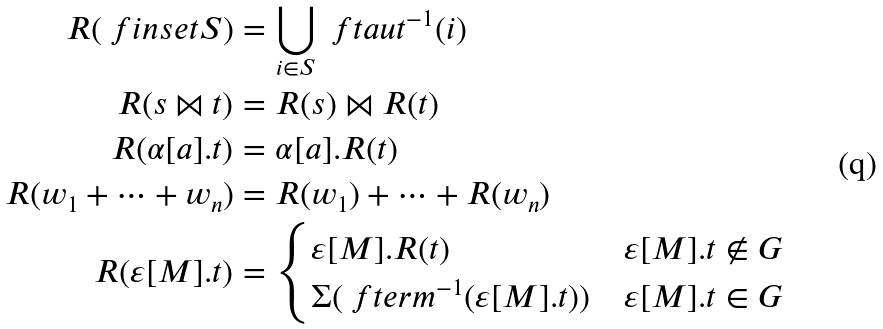Convert formula to latex. <formula><loc_0><loc_0><loc_500><loc_500>R ( \ f i n s e t { S } ) & = \bigcup _ { i \in S } \ f t a u t ^ { - 1 } ( i ) \\ R ( s \bowtie t ) & = R ( s ) \bowtie R ( t ) \\ R ( \alpha [ a ] . t ) & = \alpha [ a ] . R ( t ) \\ R ( w _ { 1 } + \cdots + w _ { n } ) & = R ( w _ { 1 } ) + \cdots + R ( w _ { n } ) \\ R ( \varepsilon [ M ] . t ) & = \begin{cases} \varepsilon [ M ] . R ( t ) & \varepsilon [ M ] . t \notin G \\ \Sigma ( \ f t e r m ^ { - 1 } ( \varepsilon [ M ] . t ) ) & \varepsilon [ M ] . t \in G \\ \end{cases}</formula> 